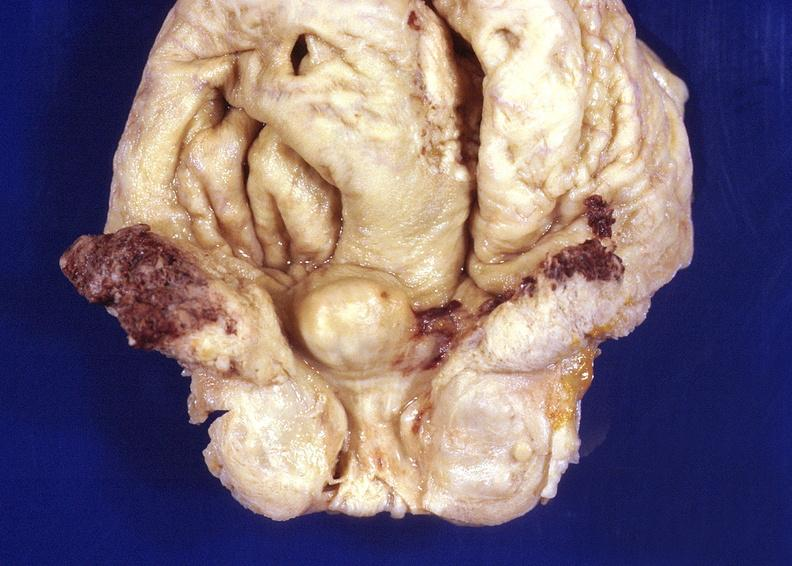does this image show prostatic hyperplasia?
Answer the question using a single word or phrase. Yes 